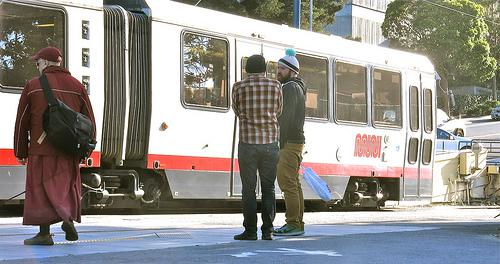Question: where are the people?
Choices:
A. Next to the train.
B. In the train.
C. Under the train.
D. On the train.
Answer with the letter. Answer: A Question: what are the people doing?
Choices:
A. Waiting.
B. Sleeping.
C. Exercising.
D. Working.
Answer with the letter. Answer: A Question: why are the people wearing jackets?
Choices:
A. They feel fun.
B. It's good to wear.
C. It's warm.
D. It's cold.
Answer with the letter. Answer: D Question: what is the train on?
Choices:
A. Gravel.
B. Tracks.
C. Grass.
D. Water.
Answer with the letter. Answer: B 